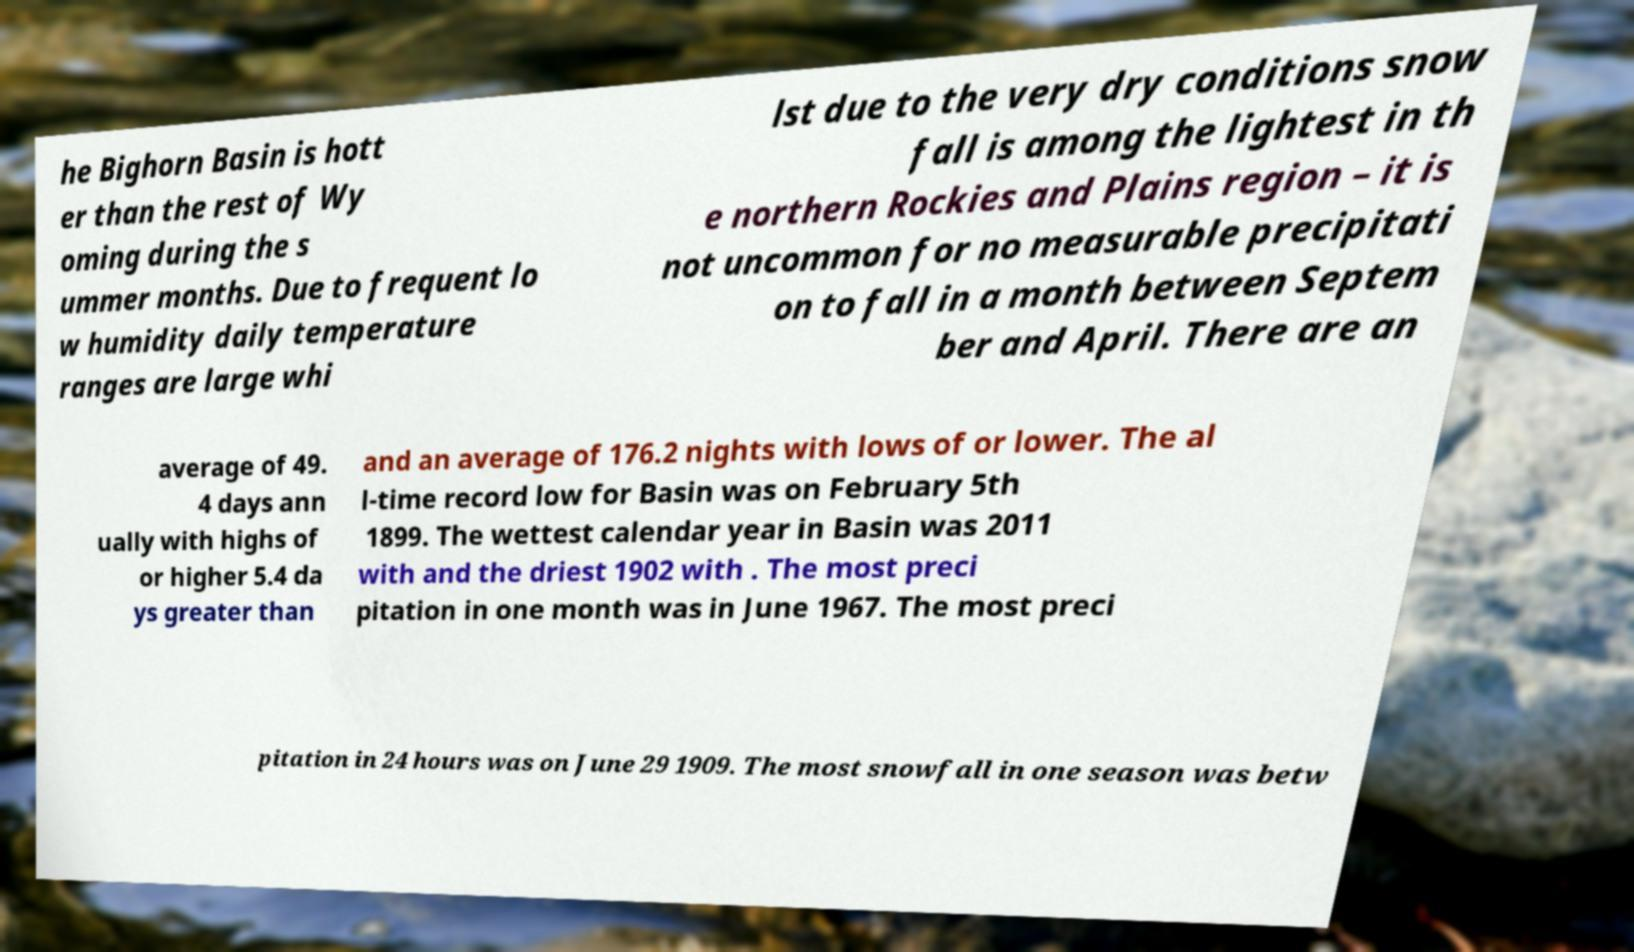For documentation purposes, I need the text within this image transcribed. Could you provide that? he Bighorn Basin is hott er than the rest of Wy oming during the s ummer months. Due to frequent lo w humidity daily temperature ranges are large whi lst due to the very dry conditions snow fall is among the lightest in th e northern Rockies and Plains region – it is not uncommon for no measurable precipitati on to fall in a month between Septem ber and April. There are an average of 49. 4 days ann ually with highs of or higher 5.4 da ys greater than and an average of 176.2 nights with lows of or lower. The al l-time record low for Basin was on February 5th 1899. The wettest calendar year in Basin was 2011 with and the driest 1902 with . The most preci pitation in one month was in June 1967. The most preci pitation in 24 hours was on June 29 1909. The most snowfall in one season was betw 